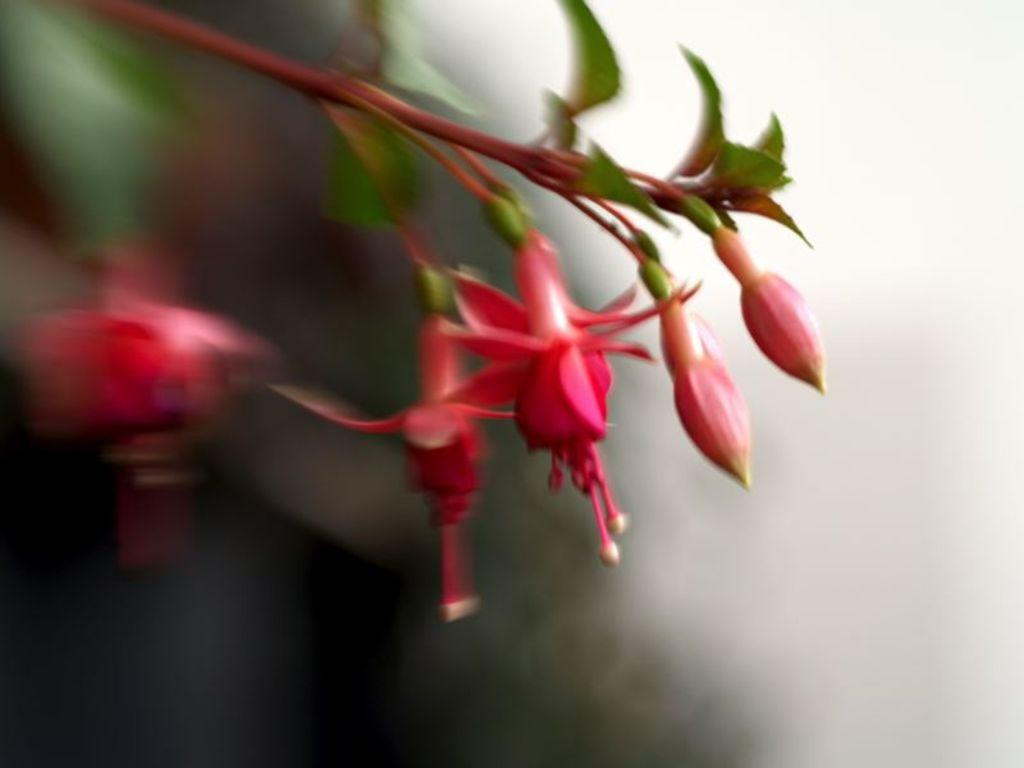What is the overall quality of the image? The picture is blurred. What can be seen in the center of the image? There are flowers, buds, and leaves of a plant in the center of the image. Can you see any grapes hanging from the leaves in the image? There are no grapes visible in the image; it features flowers, buds, and leaves of a plant. What type of sail is present in the image? There is no sail present in the image. 